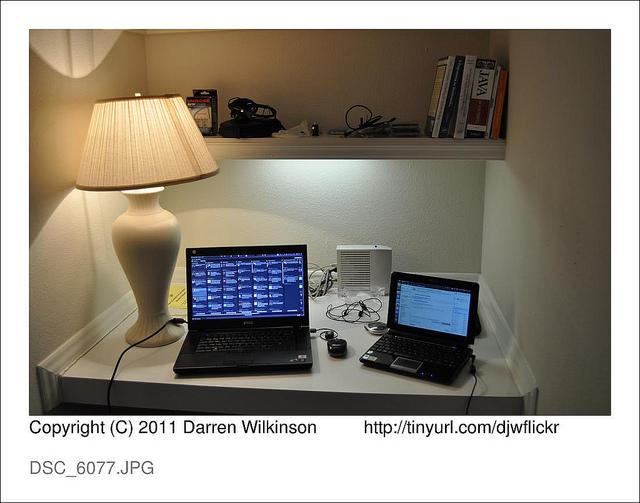What is on the top right side of the shelf?
Keep it brief. Books. Are the laptops on?
Answer briefly. Yes. How many lamps are there?
Answer briefly. 1. 